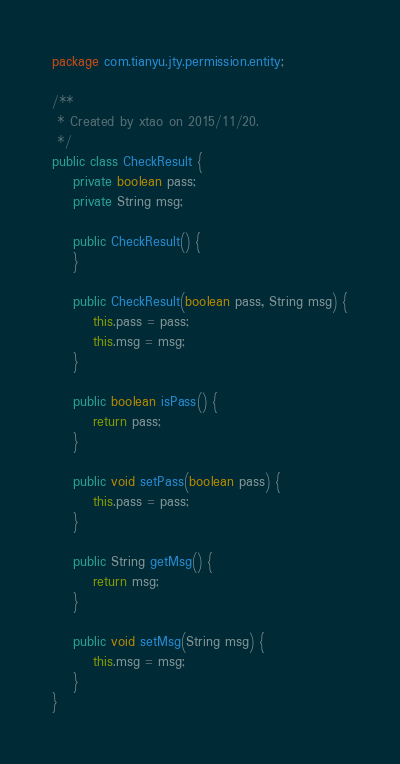<code> <loc_0><loc_0><loc_500><loc_500><_Java_>package com.tianyu.jty.permission.entity;

/**
 * Created by xtao on 2015/11/20.
 */
public class CheckResult {
    private boolean pass;
    private String msg;

    public CheckResult() {
    }

    public CheckResult(boolean pass, String msg) {
        this.pass = pass;
        this.msg = msg;
    }

    public boolean isPass() {
        return pass;
    }

    public void setPass(boolean pass) {
        this.pass = pass;
    }

    public String getMsg() {
        return msg;
    }

    public void setMsg(String msg) {
        this.msg = msg;
    }
}
</code> 